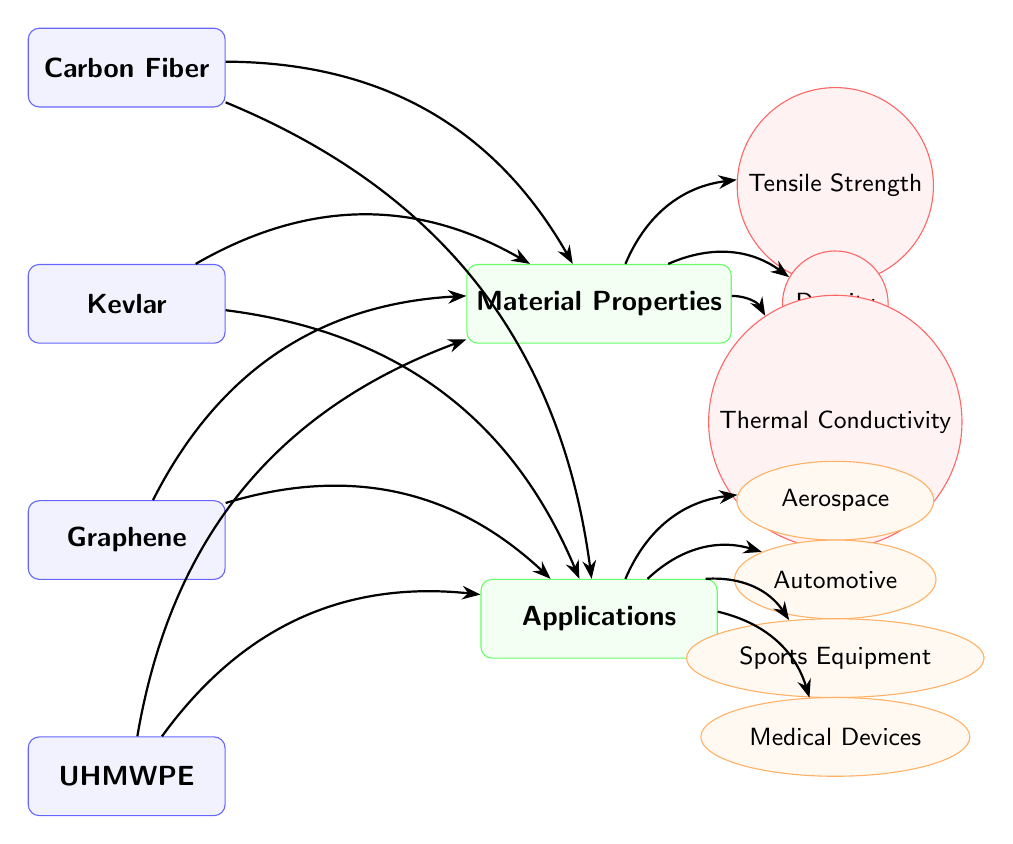What materials are represented in the diagram? The diagram shows four materials: Carbon Fiber, Kevlar, Graphene, and UHMWPE.
Answer: Carbon Fiber, Kevlar, Graphene, UHMWPE How many categories are present in the diagram? The diagram contains two categories: Material Properties and Applications.
Answer: 2 Which application is linked to the material properties category? The application linked to material properties is derived from the connections of materials to the Applications category through identified properties. Since all materials connect to properties, it indicates applications that may require these properties.
Answer: Aerospace, Automotive, Sports Equipment, Medical Devices What types of material properties are listed in the diagram? The diagram includes three material properties: Tensile Strength, Density, and Thermal Conductivity.
Answer: Tensile Strength, Density, Thermal Conductivity Which material has the highest tensile strength among those listed? The diagram does not specify values for tensile strength directly. However, it implies comparisons can be made by understanding the materials' general characteristics known in the field. For instance, Carbon Fiber is well-known for its high tensile strength relative to the others in the diagram.
Answer: Carbon Fiber From which application category does "Sports Equipment" belong? "Sports Equipment" is part of the Applications category as indicated by its position and categorization in the diagram.
Answer: Applications How many arrows are connected to the "Material Properties" category? There are three properties listed in the diagram, with each property linked by an arrow from the Material Properties category, totaling three arrows.
Answer: 3 Which material is linked to "Medical Devices" application? Given the structure of the diagram, all materials connect to applications, including Medical Devices; thus, there is no specific link to a single material, showing a broader use.
Answer: Carbon Fiber, Kevlar, Graphene, UHMWPE What kind of shape represents each material in the diagram? Each material is represented by a rectangle, which is a distinct visual characteristic that differentiates materials from categories and properties in the diagram.
Answer: Rectangle 